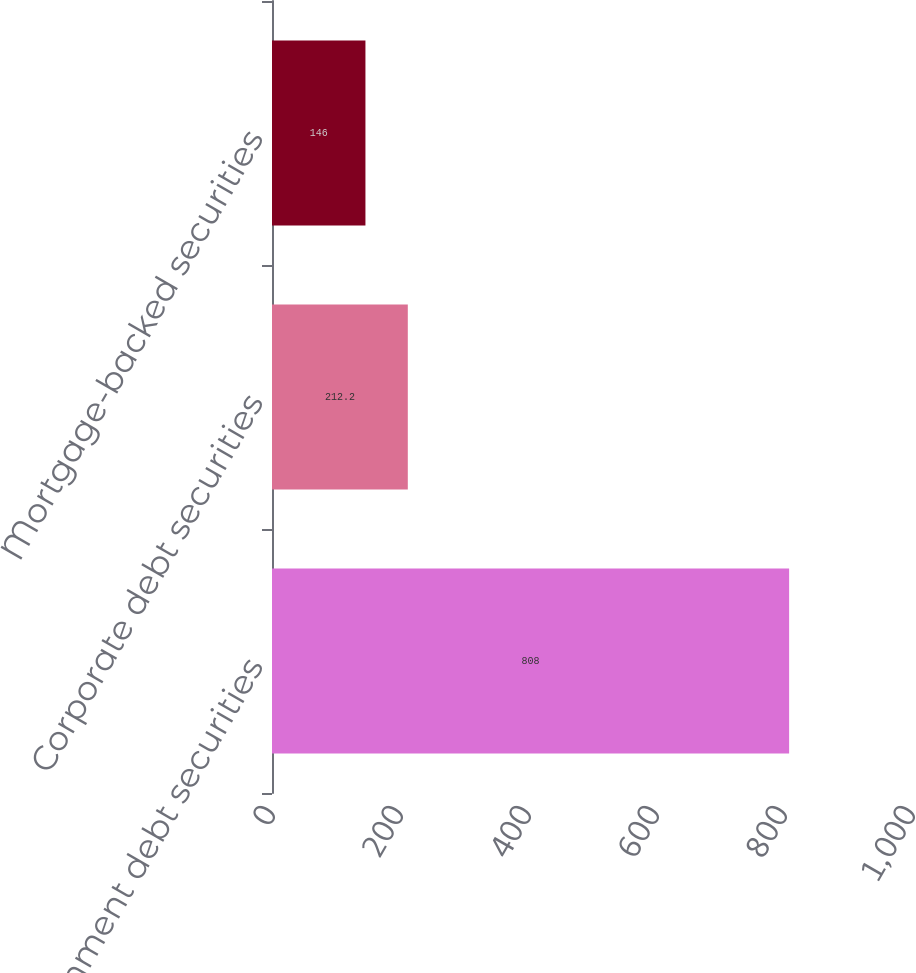Convert chart to OTSL. <chart><loc_0><loc_0><loc_500><loc_500><bar_chart><fcel>US government debt securities<fcel>Corporate debt securities<fcel>Mortgage-backed securities<nl><fcel>808<fcel>212.2<fcel>146<nl></chart> 